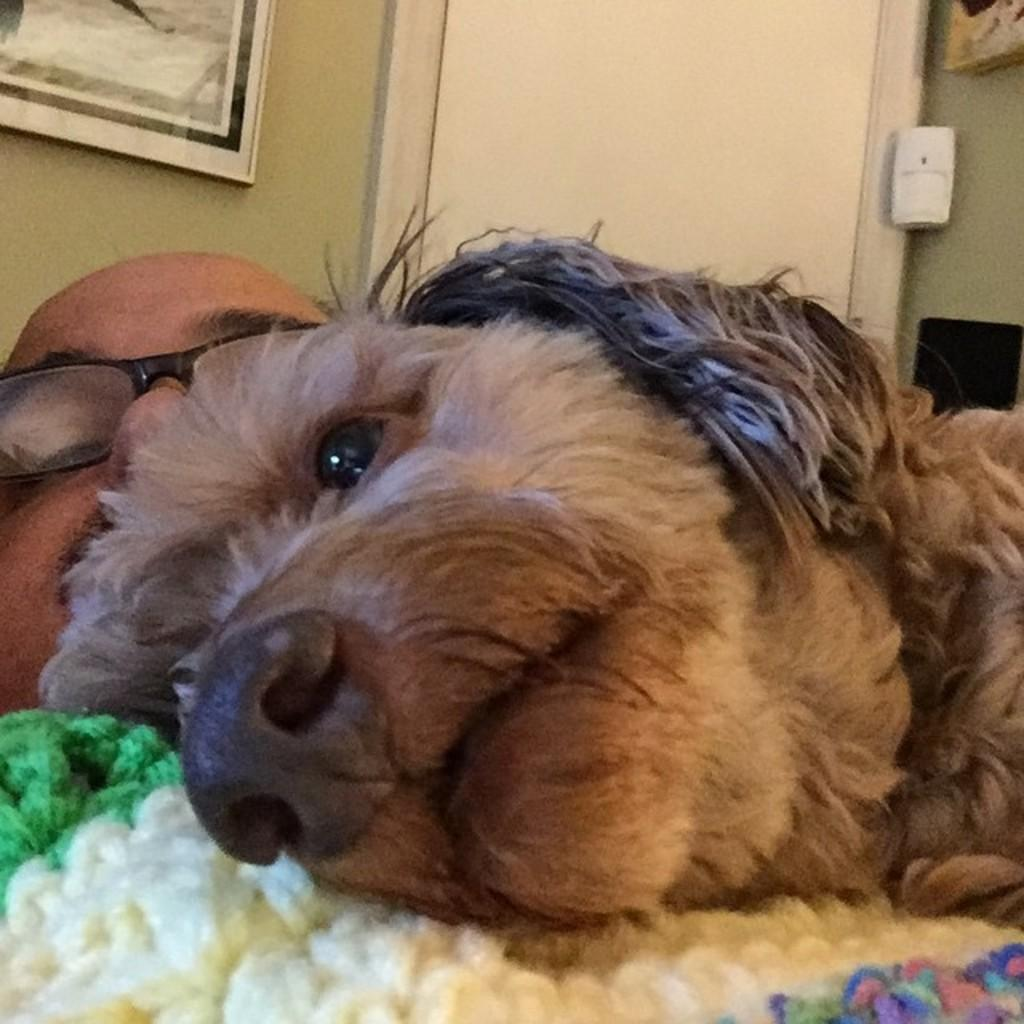What animal is present in the image? There is a dog in the image. What is the dog doing in the image? The dog is laying on a person. Can you describe the person in the image? The person is wearing spectacles. What can be seen on the wall behind the person? There is a portrait on the wall behind the person. What type of religious ceremony is taking place in the image? There is no indication of a religious ceremony in the image; it features a dog laying on a person with spectacles and a portrait on the wall. 